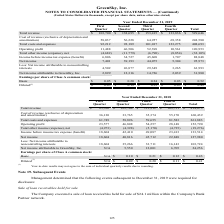According to Greensky's financial document, What was the total revenue for 2019? According to the financial document, 529,646 (in thousands). The relevant text states: "revenue $ 103,700 $ 138,695 $ 153,415 $ 133,836 $ 529,646 Cost of revenue (exclusive of depreciation and amortization) 58,037 56,228 64,957 69,358 248,580 To..." Also, What was the operating profit in the first quarter? According to the financial document, 11,488 (in thousands). The relevant text states: "2 92,189 101,017 123,275 408,693 Operating profit 11,488 46,506 52,398 10,561 120,953 Total other income (expense), net (4,682) (11,779) (6,790) (8,854) (32..." Also, What was the net income in the third quarter? According to the financial document, 44,075 (in thousands). The relevant text states: "4,727 45,608 1,707 88,848 Net income 7,401 39,193 44,075 5,304 95,973 Less: Net income attributable to noncontrolling interests 4,502 26,877 29,349 3,265 63..." Also, How many quarters did the the Net Income exceed $10,000 thousand? Counting the relevant items in the document: second quarter, third quarter, I find 2 instances. The key data points involved are: second quarter, third quarter. Also, can you calculate: What was the change in operating profit between the third and fourth quarter? Based on the calculation: 10,561-52,398, the result is -41837 (in thousands). This is based on the information: "17 123,275 408,693 Operating profit 11,488 46,506 52,398 10,561 120,953 Total other income (expense), net (4,682) (11,779) (6,790) (8,854) (32,105) Income b 275 408,693 Operating profit 11,488 46,506 ..." The key data points involved are: 10,561, 52,398. Also, can you calculate: What was the percentage change in the basic earnings per share of Class A common stock between the first and second quarter? To answer this question, I need to perform calculations using the financial data. The calculation is: (0.20-0.05)/0.05, which equals 300 (percentage). This is based on the information: "rnings per share of Class A common stock: Basic $ 0.05 $ 0.20 $ 0.24 $ 0.03 $ 0.52 Diluted (1) $ 0.05 $ 0.19 $ 0.23 $ 0.03 $ 0.49 per share of Class A common stock: Basic $ 0.05 $ 0.20 $ 0.24 $ 0.03 $..." The key data points involved are: 0.05, 0.20. 